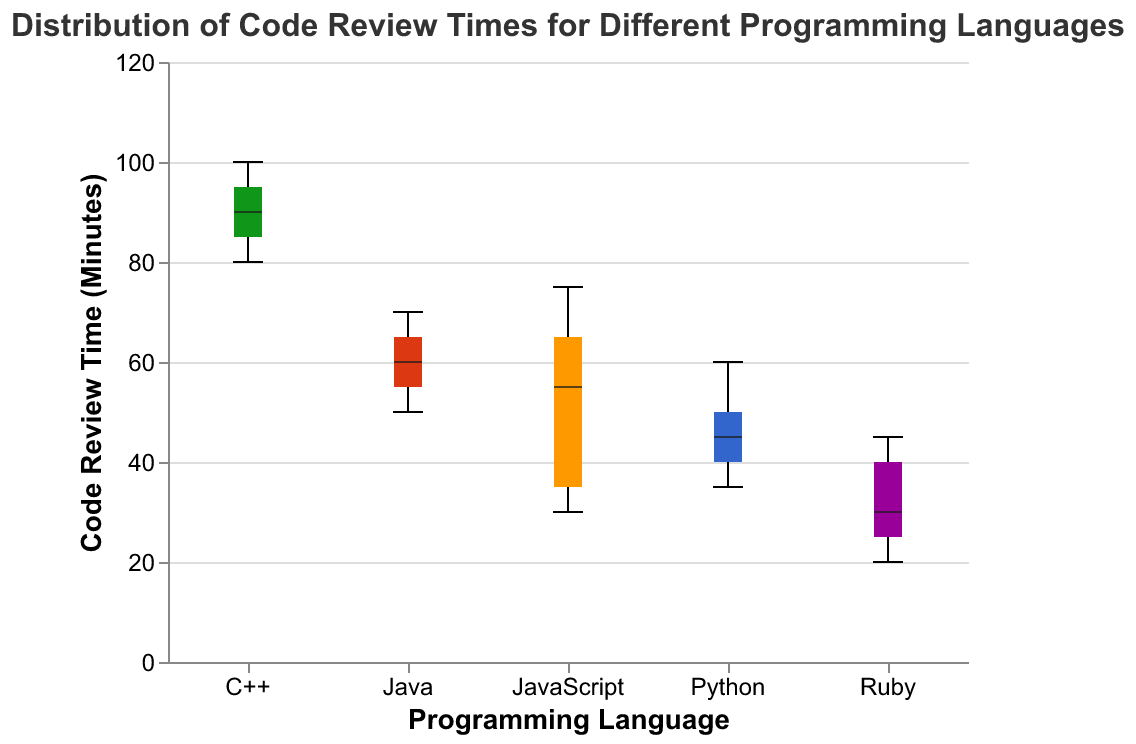Which programming language has the widest range of code review times? To determine the widest range, we need to compare the difference between the maximum and minimum values for each programming language. C++ ranges from 80 to 100 minutes, giving it the widest range of 20 minutes.
Answer: C++ Which language has the shortest median code review time? The median value is displayed as the middle line in the boxplot of each language. Ruby has its median line at 30 minutes.
Answer: Ruby What is the maximum code review time for Python? The top whisker represents the maximum value in a box plot. Python's top whisker reaches 60 minutes.
Answer: 60 minutes How does the median code review time for Java compare to JavaScript? Look at the middle line of both Java and JavaScript box plots to compare their medians. Java's median is at 60 minutes, while JavaScript's median is at 55 minutes.
Answer: Java is higher Which language has the smallest interquartile range (IQR)? The IQR is the length of the box, which spans the first quartile (25th percentile) to the third quartile (75th percentile). Ruby has the smallest box, indicating the smallest IQR.
Answer: Ruby What is the interquartile range (IQR) for JavaScript? The IQR is the distance between the lower quartile (25th percentile) and the upper quartile (75th percentile). For JavaScript, this range spans from 35 to 65 minutes.
Answer: 30 minutes Which programming language shows the greatest variability in code review times? Greatest variability is indicated by the overall span from minimum to maximum. C++ shows the greatest variability from 80 to 100 minutes.
Answer: C++ Is there any programming language whose code review times are only in the lower half of the y-axis scale (0 to 60 minutes)? By examining the upper whiskers, Ruby's highest value is 45 minutes, making it the only language with times entirely below 60 minutes.
Answer: Ruby What are the median code review times for each programming language? The medians are depicted as the thick central lines within the boxes. Python: 45, Java: 60, JavaScript: 55, C++: 90, and Ruby: 30.
Answer: Python: 45, Java: 60, JavaScript: 55, C++: 90, Ruby: 30 